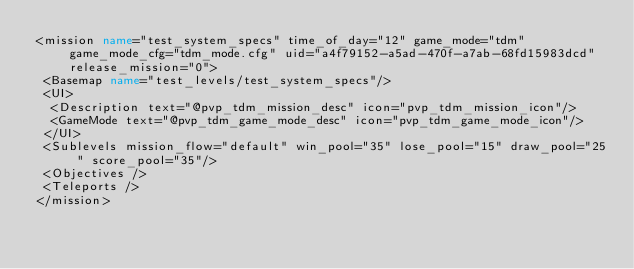<code> <loc_0><loc_0><loc_500><loc_500><_XML_><mission name="test_system_specs" time_of_day="12" game_mode="tdm" game_mode_cfg="tdm_mode.cfg" uid="a4f79152-a5ad-470f-a7ab-68fd15983dcd" release_mission="0">
 <Basemap name="test_levels/test_system_specs"/>
 <UI>
  <Description text="@pvp_tdm_mission_desc" icon="pvp_tdm_mission_icon"/>
  <GameMode text="@pvp_tdm_game_mode_desc" icon="pvp_tdm_game_mode_icon"/>
 </UI>
 <Sublevels mission_flow="default" win_pool="35" lose_pool="15" draw_pool="25" score_pool="35"/>
 <Objectives />
 <Teleports />
</mission>
</code> 